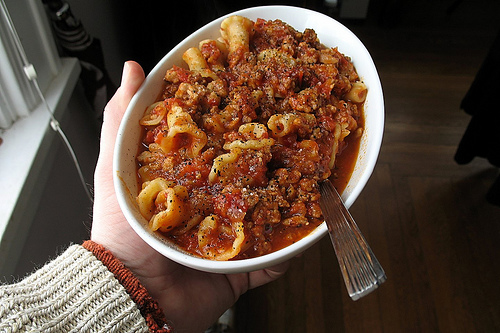<image>
Can you confirm if the food is in the bowl? Yes. The food is contained within or inside the bowl, showing a containment relationship. 